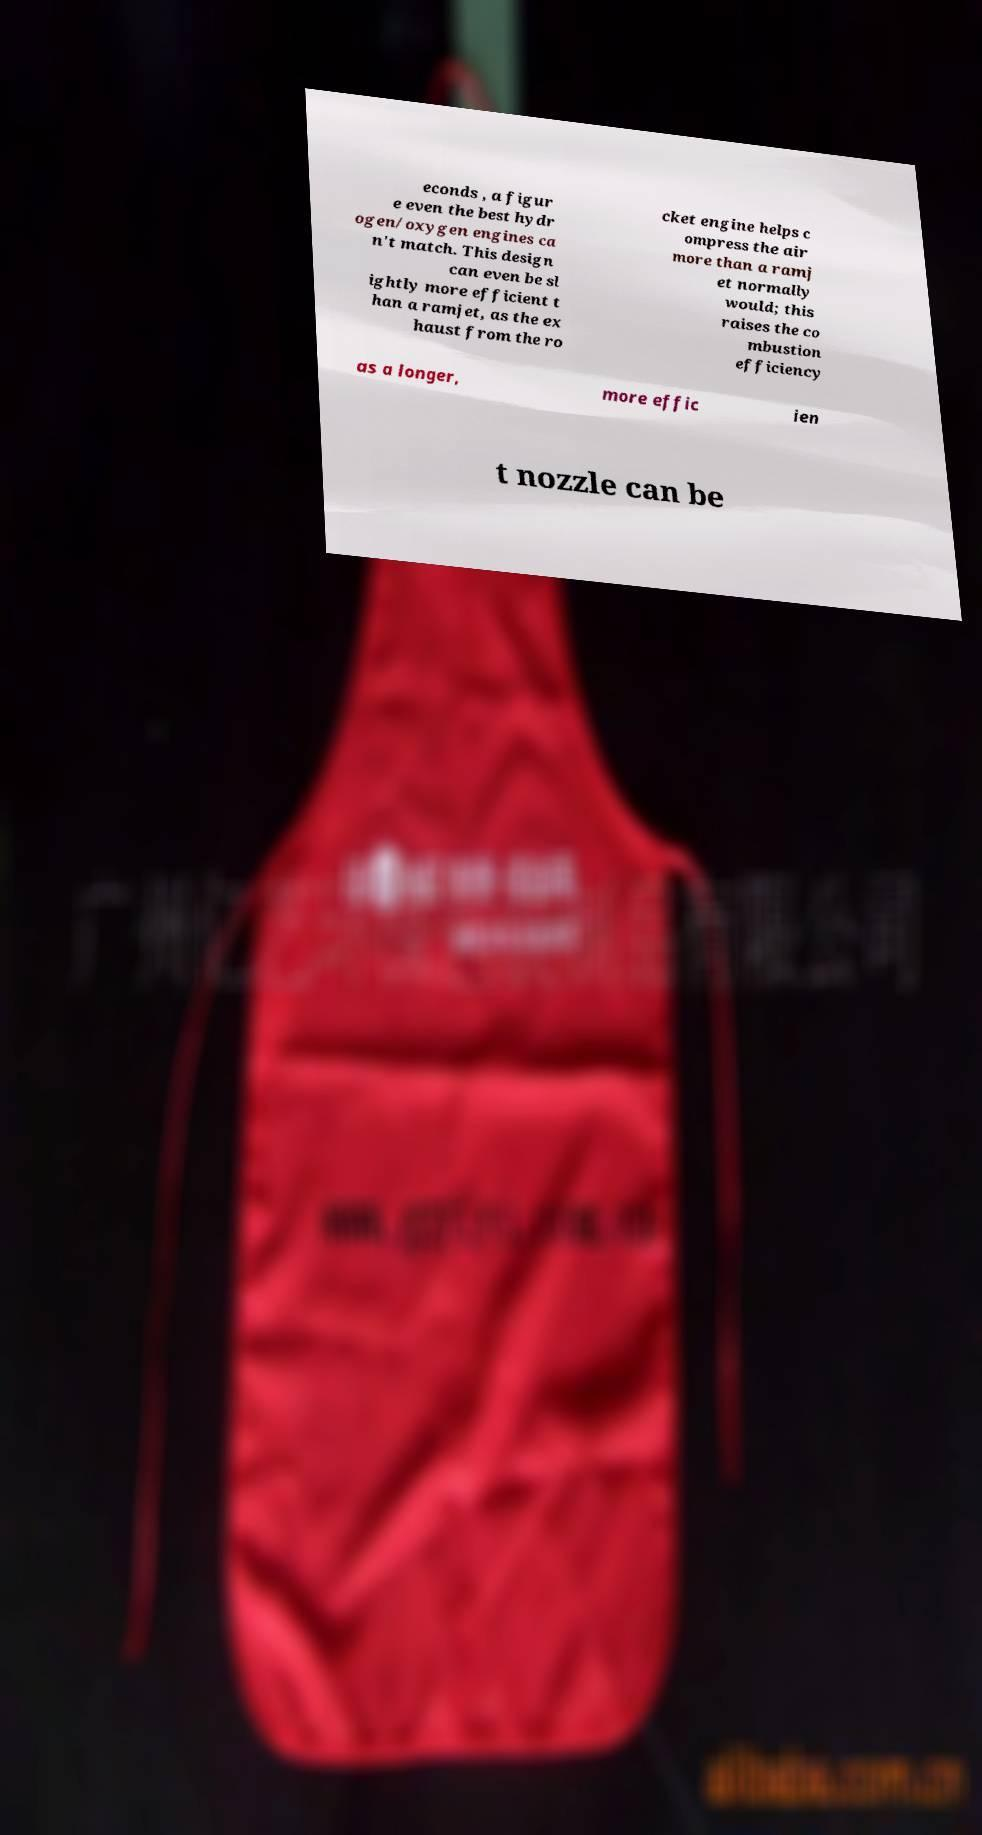Can you read and provide the text displayed in the image?This photo seems to have some interesting text. Can you extract and type it out for me? econds , a figur e even the best hydr ogen/oxygen engines ca n't match. This design can even be sl ightly more efficient t han a ramjet, as the ex haust from the ro cket engine helps c ompress the air more than a ramj et normally would; this raises the co mbustion efficiency as a longer, more effic ien t nozzle can be 